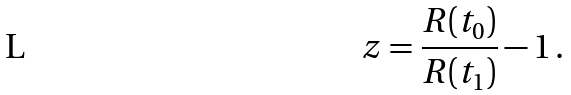<formula> <loc_0><loc_0><loc_500><loc_500>z = \frac { R ( t _ { 0 } ) } { R ( t _ { 1 } ) } - 1 \, .</formula> 